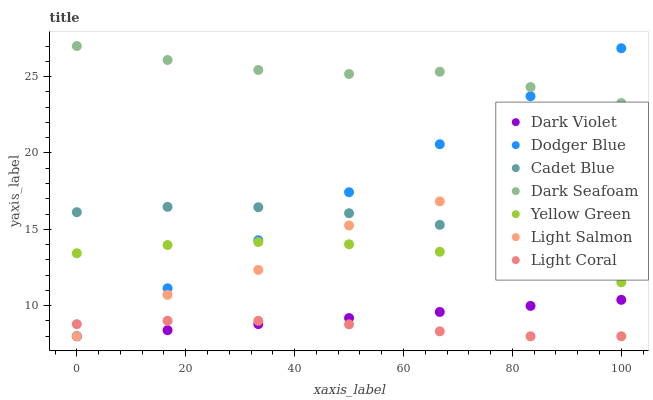Does Light Coral have the minimum area under the curve?
Answer yes or no. Yes. Does Dark Seafoam have the maximum area under the curve?
Answer yes or no. Yes. Does Cadet Blue have the minimum area under the curve?
Answer yes or no. No. Does Cadet Blue have the maximum area under the curve?
Answer yes or no. No. Is Dark Violet the smoothest?
Answer yes or no. Yes. Is Light Salmon the roughest?
Answer yes or no. Yes. Is Cadet Blue the smoothest?
Answer yes or no. No. Is Cadet Blue the roughest?
Answer yes or no. No. Does Light Salmon have the lowest value?
Answer yes or no. Yes. Does Cadet Blue have the lowest value?
Answer yes or no. No. Does Dark Seafoam have the highest value?
Answer yes or no. Yes. Does Cadet Blue have the highest value?
Answer yes or no. No. Is Cadet Blue less than Dark Seafoam?
Answer yes or no. Yes. Is Dark Seafoam greater than Cadet Blue?
Answer yes or no. Yes. Does Light Salmon intersect Dodger Blue?
Answer yes or no. Yes. Is Light Salmon less than Dodger Blue?
Answer yes or no. No. Is Light Salmon greater than Dodger Blue?
Answer yes or no. No. Does Cadet Blue intersect Dark Seafoam?
Answer yes or no. No. 